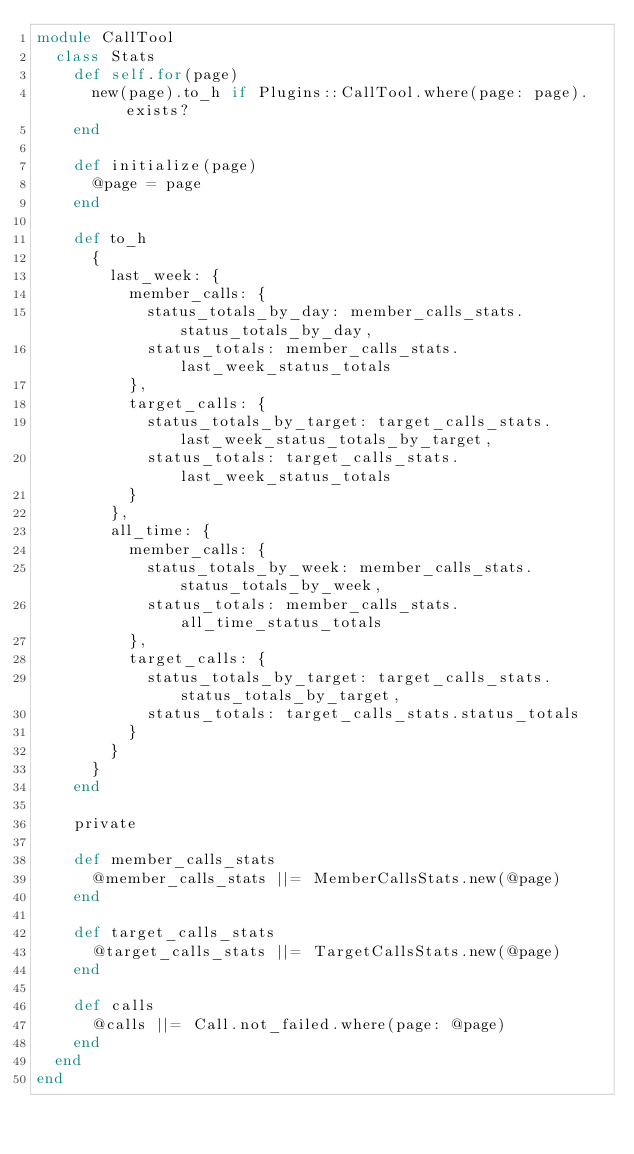Convert code to text. <code><loc_0><loc_0><loc_500><loc_500><_Ruby_>module CallTool
  class Stats
    def self.for(page)
      new(page).to_h if Plugins::CallTool.where(page: page).exists?
    end

    def initialize(page)
      @page = page
    end

    def to_h
      {
        last_week: {
          member_calls: {
            status_totals_by_day: member_calls_stats.status_totals_by_day,
            status_totals: member_calls_stats.last_week_status_totals
          },
          target_calls: {
            status_totals_by_target: target_calls_stats.last_week_status_totals_by_target,
            status_totals: target_calls_stats.last_week_status_totals
          }
        },
        all_time: {
          member_calls: {
            status_totals_by_week: member_calls_stats.status_totals_by_week,
            status_totals: member_calls_stats.all_time_status_totals
          },
          target_calls: {
            status_totals_by_target: target_calls_stats.status_totals_by_target,
            status_totals: target_calls_stats.status_totals
          }
        }
      }
    end

    private

    def member_calls_stats
      @member_calls_stats ||= MemberCallsStats.new(@page)
    end

    def target_calls_stats
      @target_calls_stats ||= TargetCallsStats.new(@page)
    end

    def calls
      @calls ||= Call.not_failed.where(page: @page)
    end
  end
end
</code> 